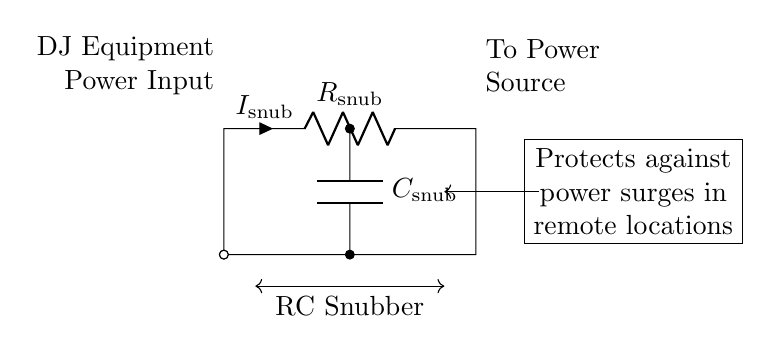What is the value of the resistor? The value of the resistor is labeled as R snub. This indicates that it is a specific resistor value used in the RC snubber circuit to protect DJ equipment.
Answer: R snub What does the capacitor in this circuit do? The capacitor, labeled as C snub, is responsible for shunting high-frequency voltage spikes to ground. This helps to smooth out power surges, protecting the connected equipment.
Answer: Shunts voltage spikes What are the two main components of this circuit? The two main components are a resistor (R snub) and a capacitor (C snub). These components work together to form the RC snubber circuit used for surge protection.
Answer: Resistor and capacitor What is the purpose of the RC snubber circuit? The purpose of the RC snubber circuit is to protect DJ equipment from power surges when operating in remote locations where power stability can be an issue.
Answer: Protect DJ equipment How does this circuit configuration handle power surges? The RC snubber circuit configuration works by absorbing and dissipating the energy from power surges and transient spikes, preventing them from reaching sensitive electronic components of the DJ equipment.
Answer: Absorbs and dissipates energy What voltage is the power input for the DJ equipment? The voltage input for the DJ equipment is not explicitly indicated on the circuit, but typically it would match the standard operating voltage of the connected equipment, such as 120V or 240V AC.
Answer: Not specified What is the direction of current in this circuit? The current flows from the power input towards the power source through the resistor and capacitor, following conventional current flow from positive to negative.
Answer: From DJ equipment to power source 